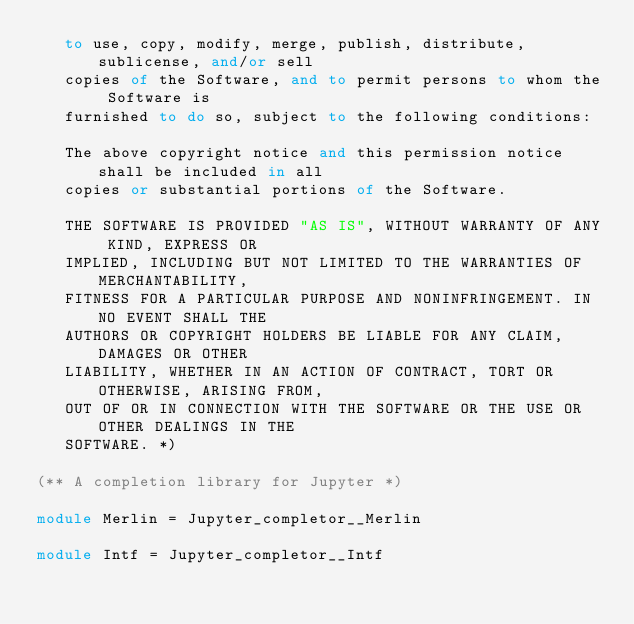<code> <loc_0><loc_0><loc_500><loc_500><_OCaml_>   to use, copy, modify, merge, publish, distribute, sublicense, and/or sell
   copies of the Software, and to permit persons to whom the Software is
   furnished to do so, subject to the following conditions:

   The above copyright notice and this permission notice shall be included in all
   copies or substantial portions of the Software.

   THE SOFTWARE IS PROVIDED "AS IS", WITHOUT WARRANTY OF ANY KIND, EXPRESS OR
   IMPLIED, INCLUDING BUT NOT LIMITED TO THE WARRANTIES OF MERCHANTABILITY,
   FITNESS FOR A PARTICULAR PURPOSE AND NONINFRINGEMENT. IN NO EVENT SHALL THE
   AUTHORS OR COPYRIGHT HOLDERS BE LIABLE FOR ANY CLAIM, DAMAGES OR OTHER
   LIABILITY, WHETHER IN AN ACTION OF CONTRACT, TORT OR OTHERWISE, ARISING FROM,
   OUT OF OR IN CONNECTION WITH THE SOFTWARE OR THE USE OR OTHER DEALINGS IN THE
   SOFTWARE. *)

(** A completion library for Jupyter *)

module Merlin = Jupyter_completor__Merlin

module Intf = Jupyter_completor__Intf
</code> 